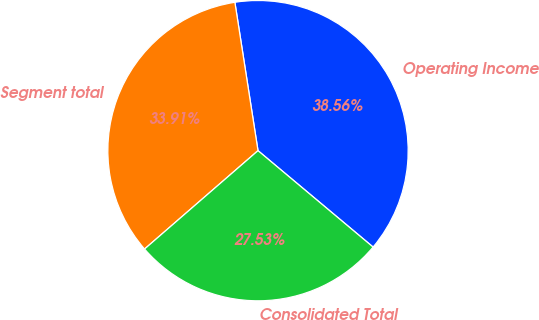Convert chart to OTSL. <chart><loc_0><loc_0><loc_500><loc_500><pie_chart><fcel>Operating Income<fcel>Segment total<fcel>Consolidated Total<nl><fcel>38.56%<fcel>33.91%<fcel>27.53%<nl></chart> 